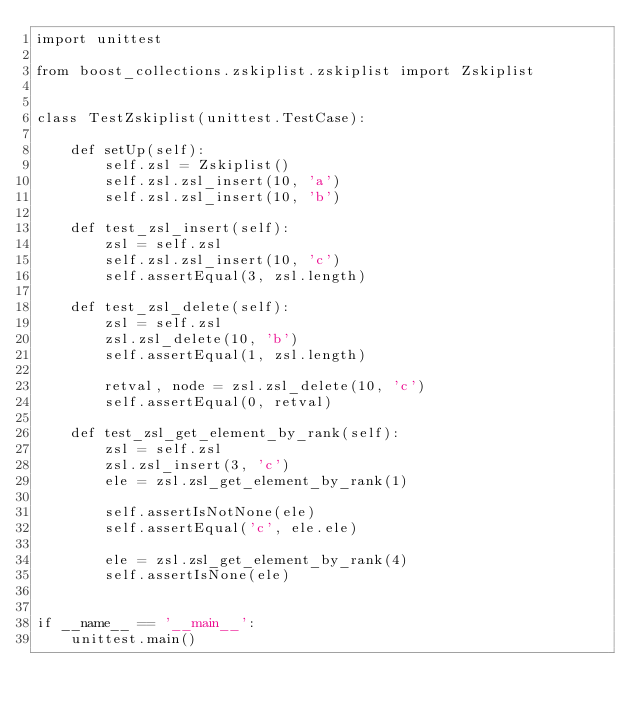Convert code to text. <code><loc_0><loc_0><loc_500><loc_500><_Python_>import unittest

from boost_collections.zskiplist.zskiplist import Zskiplist


class TestZskiplist(unittest.TestCase):

    def setUp(self):
        self.zsl = Zskiplist()
        self.zsl.zsl_insert(10, 'a')
        self.zsl.zsl_insert(10, 'b')

    def test_zsl_insert(self):
        zsl = self.zsl
        self.zsl.zsl_insert(10, 'c')
        self.assertEqual(3, zsl.length)

    def test_zsl_delete(self):
        zsl = self.zsl
        zsl.zsl_delete(10, 'b')
        self.assertEqual(1, zsl.length)

        retval, node = zsl.zsl_delete(10, 'c')
        self.assertEqual(0, retval)

    def test_zsl_get_element_by_rank(self):
        zsl = self.zsl
        zsl.zsl_insert(3, 'c')
        ele = zsl.zsl_get_element_by_rank(1)

        self.assertIsNotNone(ele)
        self.assertEqual('c', ele.ele)

        ele = zsl.zsl_get_element_by_rank(4)
        self.assertIsNone(ele)


if __name__ == '__main__':
    unittest.main()
</code> 